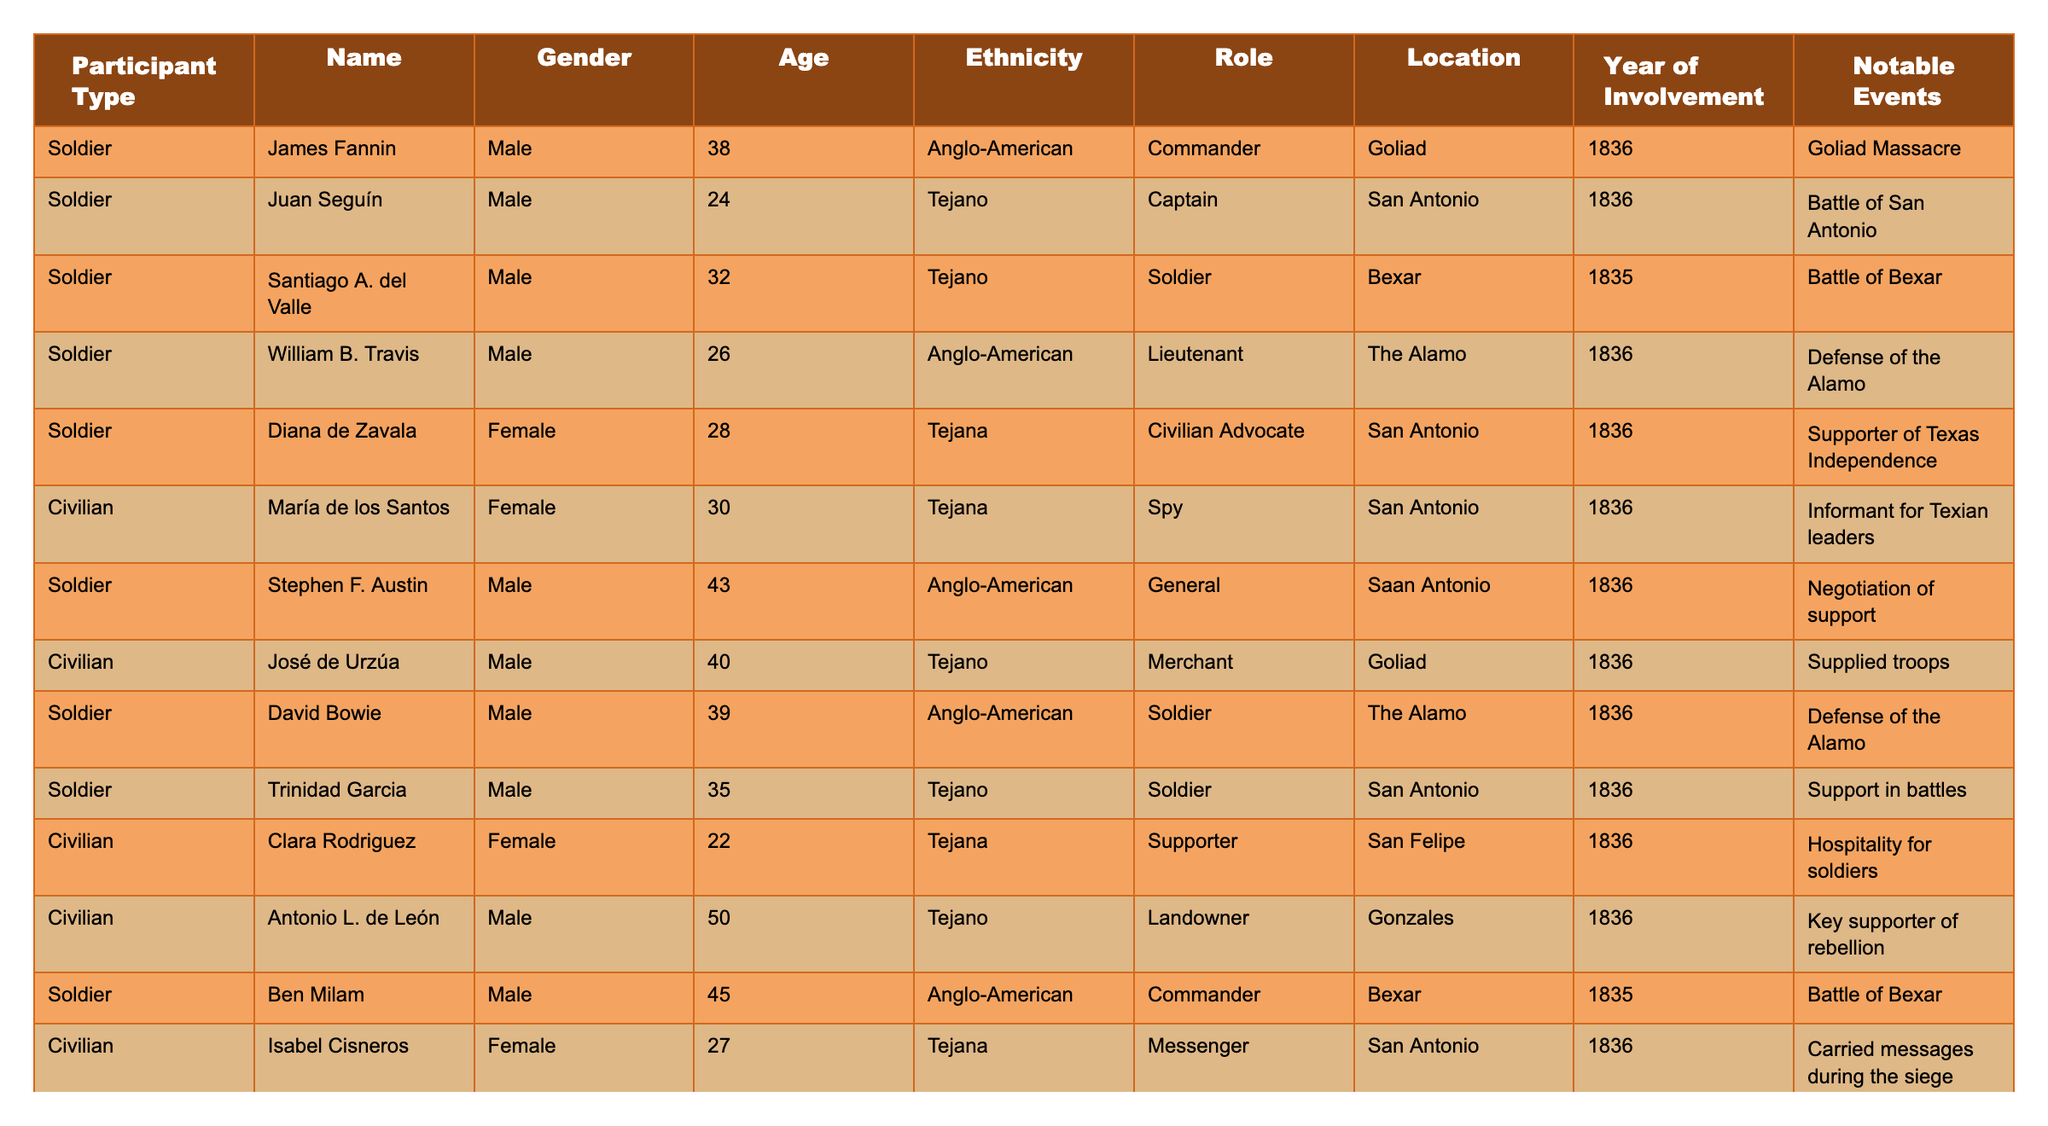What is the age of Juan Seguín? The table lists Juan Seguín as 24 years old in the Age column.
Answer: 24 How many participants are Tejano? By counting the individuals marked as Tejano in the Ethnicity column, we find that there are five Tejano participants.
Answer: 5 Which participant has the role of General? The table states that Stephen F. Austin holds the role of General.
Answer: Stephen F. Austin Are there any female military participants listed? The table indicates that there are no females classified as Soldiers, only Diana de Zavala who is a Civilian Advocate.
Answer: No What is the most common location where the participants were involved? After reviewing the Location column, San Antonio appears most frequently, associated with five participants.
Answer: San Antonio What was the average age of all participants? Summing all ages (38 + 24 + 32 + 26 + 28 + 30 + 43 + 40 + 39 + 35 + 22 + 50 + 27 + 29 + 35) gives 565. Dividing this by the total number of participants (15) gives an average age of 37.67.
Answer: 37.67 Which participant had the notable event of the Goliad Massacre? The table shows that James Fannin was involved in the Goliad Massacre.
Answer: James Fannin Is there any participant who participated in both battles at Bexar? The roles indicate that both Ben Milam and Joaquín Ramírez y Cérvantes participated in battles at Bexar, confirming their involvement.
Answer: Yes What role did Clara Rodriguez have during the revolution? Clara Rodriguez is noted as a Supporter, providing hospitality for soldiers.
Answer: Supporter Who is the oldest participant listed, and what is their age? By examining the Age column, Antonio L. de León is the oldest participant listed at 50 years old.
Answer: Antonio L. de León, 50 What percentage of participants were female? There are 5 females out of 15 total participants, which computes to (5/15)*100 = 33.33%.
Answer: 33.33% List the names of those involved in the defense of the Alamo. The table indicates that William B. Travis and David Bowie were both involved in the defense of the Alamo.
Answer: William B. Travis, David Bowie Which participant type has the most individuals in the list? Upon counting, there are 10 Soldiers and 5 Civilians, making Soldiers the most common participant type.
Answer: Soldiers Is the role of Merchant associated with a male or female participant? The table indicates José de Urzúa, a male, holds the role of Merchant.
Answer: Male What is the notable event for the participant named Ramona Santibáñez? According to the table, Ramona Santibáñez provided aid to wounded soldiers.
Answer: Provided aid to wounded soldiers 